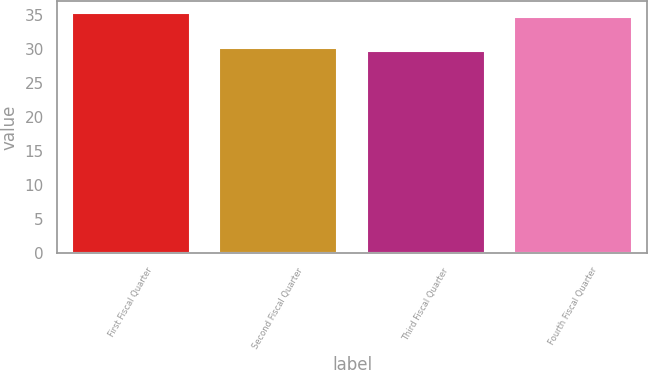<chart> <loc_0><loc_0><loc_500><loc_500><bar_chart><fcel>First Fiscal Quarter<fcel>Second Fiscal Quarter<fcel>Third Fiscal Quarter<fcel>Fourth Fiscal Quarter<nl><fcel>35.22<fcel>30.14<fcel>29.63<fcel>34.71<nl></chart> 